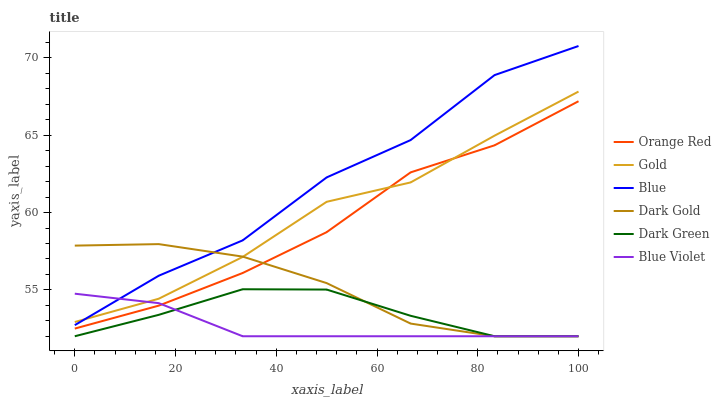Does Blue Violet have the minimum area under the curve?
Answer yes or no. Yes. Does Blue have the maximum area under the curve?
Answer yes or no. Yes. Does Gold have the minimum area under the curve?
Answer yes or no. No. Does Gold have the maximum area under the curve?
Answer yes or no. No. Is Blue Violet the smoothest?
Answer yes or no. Yes. Is Blue the roughest?
Answer yes or no. Yes. Is Gold the smoothest?
Answer yes or no. No. Is Gold the roughest?
Answer yes or no. No. Does Gold have the lowest value?
Answer yes or no. No. Does Blue have the highest value?
Answer yes or no. Yes. Does Gold have the highest value?
Answer yes or no. No. Is Dark Green less than Blue?
Answer yes or no. Yes. Is Gold greater than Dark Green?
Answer yes or no. Yes. Does Blue Violet intersect Orange Red?
Answer yes or no. Yes. Is Blue Violet less than Orange Red?
Answer yes or no. No. Is Blue Violet greater than Orange Red?
Answer yes or no. No. Does Dark Green intersect Blue?
Answer yes or no. No. 